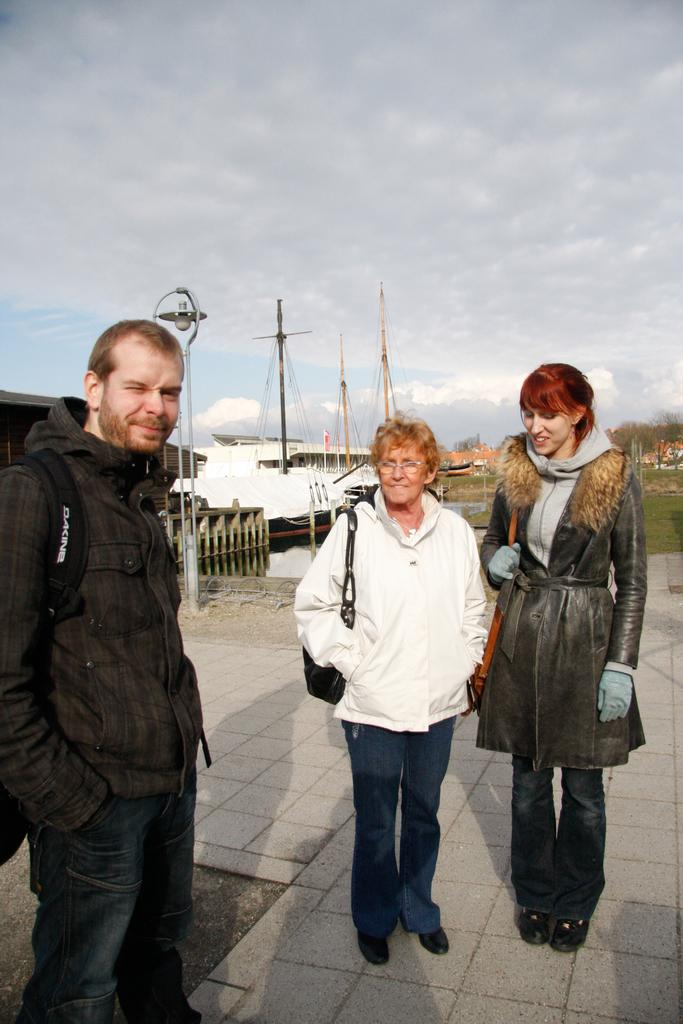What are the people in the image doing? The persons standing on the ground in the image are not performing any specific action. What can be seen in the distance behind the people? In the background, there is water, boats, the ground, buildings, trees, and the sky visible. Can you describe the natural elements present in the image? The natural elements in the image include water, trees, and the sky. What type of brake is visible on the boats in the image? There are no visible brakes on the boats in the image. 